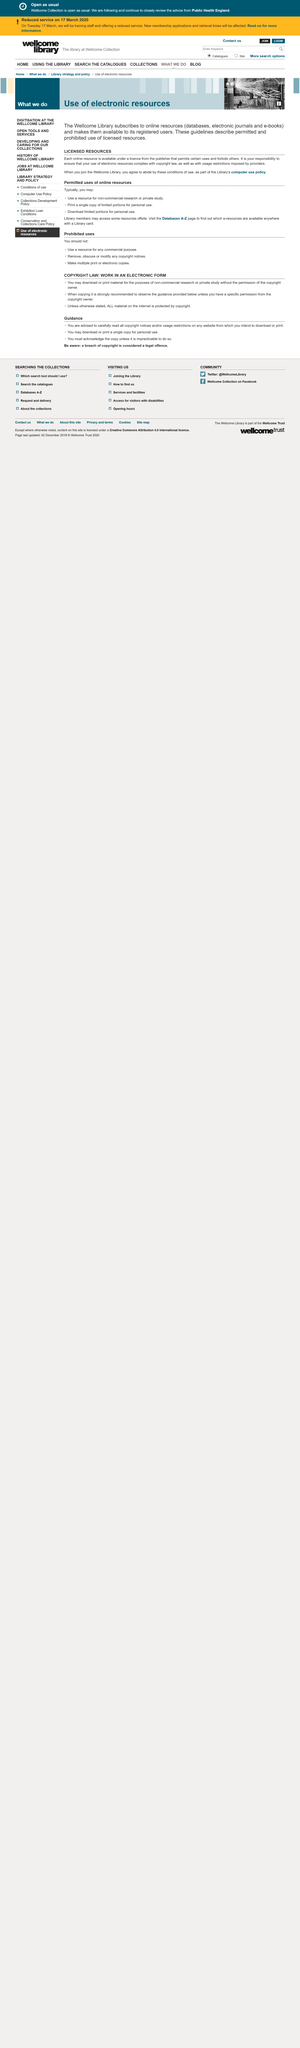Draw attention to some important aspects in this diagram. The Library subscribes to databases, electronic journals, and e-books under licenses from the publisher, which provide online resources for the purpose of accessing and using the information they contain. The conditions of use for electronic resources are governed by the Library's computer use policy. The Wellcome Library's online resources can only be accessed by registered users. 